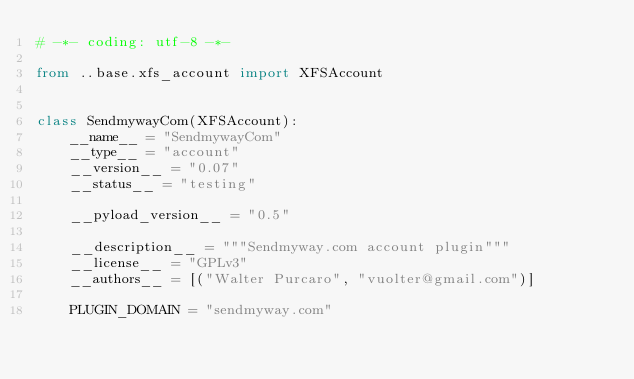<code> <loc_0><loc_0><loc_500><loc_500><_Python_># -*- coding: utf-8 -*-

from ..base.xfs_account import XFSAccount


class SendmywayCom(XFSAccount):
    __name__ = "SendmywayCom"
    __type__ = "account"
    __version__ = "0.07"
    __status__ = "testing"

    __pyload_version__ = "0.5"

    __description__ = """Sendmyway.com account plugin"""
    __license__ = "GPLv3"
    __authors__ = [("Walter Purcaro", "vuolter@gmail.com")]

    PLUGIN_DOMAIN = "sendmyway.com"
</code> 